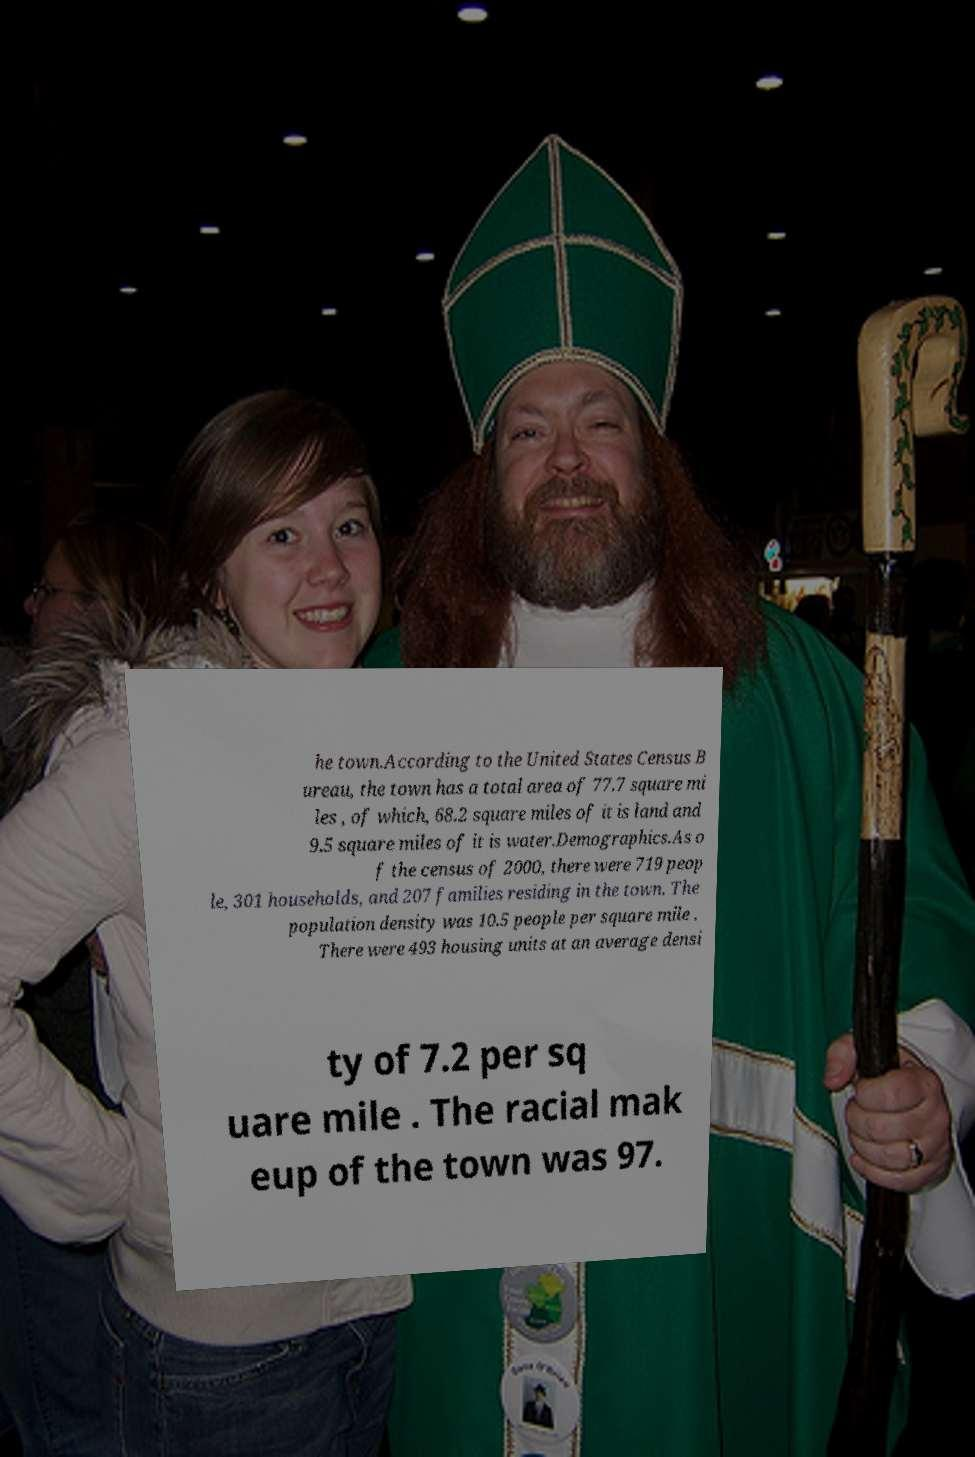There's text embedded in this image that I need extracted. Can you transcribe it verbatim? he town.According to the United States Census B ureau, the town has a total area of 77.7 square mi les , of which, 68.2 square miles of it is land and 9.5 square miles of it is water.Demographics.As o f the census of 2000, there were 719 peop le, 301 households, and 207 families residing in the town. The population density was 10.5 people per square mile . There were 493 housing units at an average densi ty of 7.2 per sq uare mile . The racial mak eup of the town was 97. 